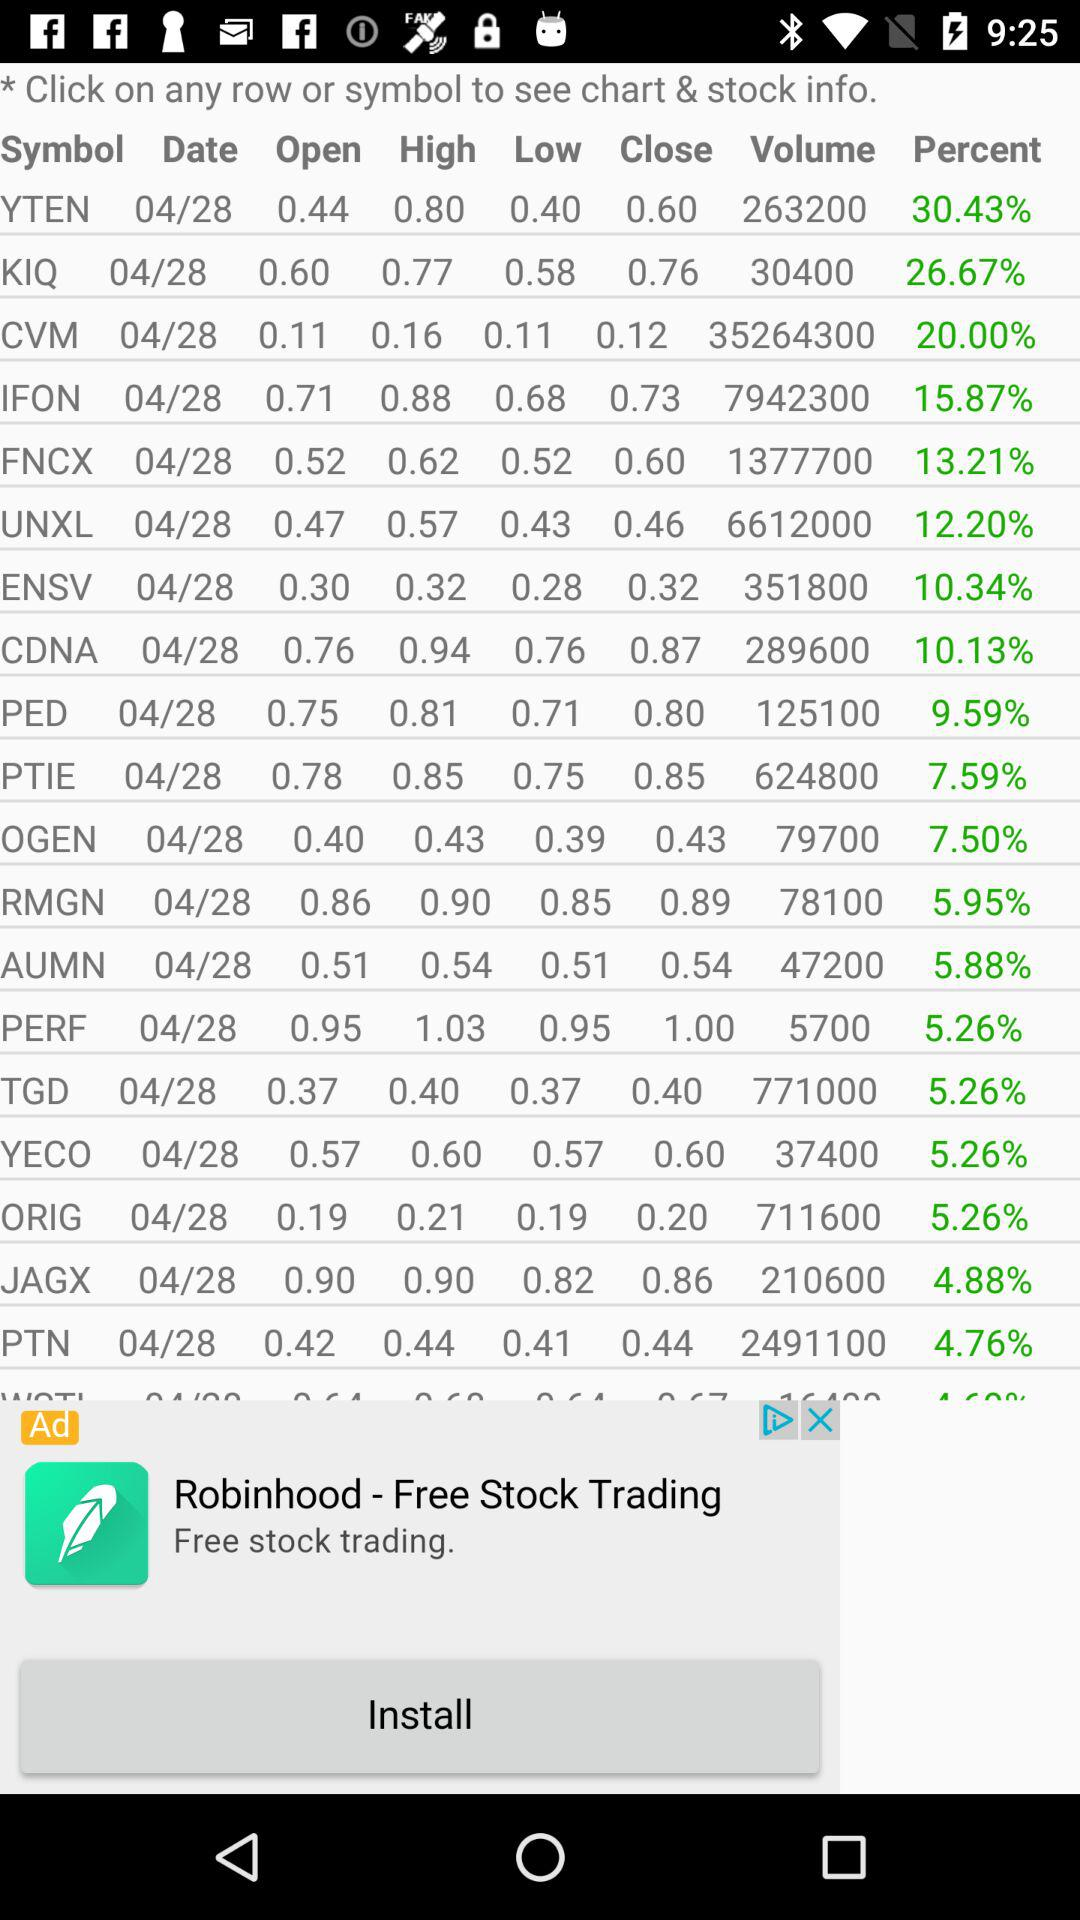What is the percentage of TGD? The percentage of TGD is 5.26. 